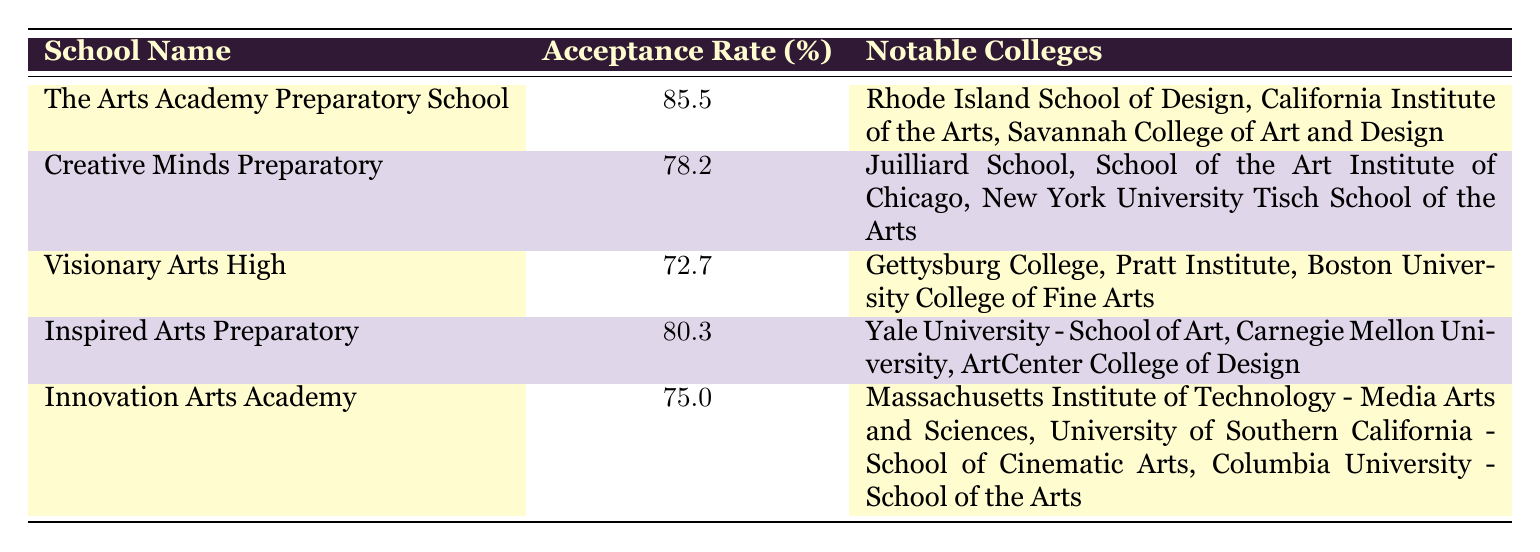What is the college acceptance rate for The Arts Academy Preparatory School? The college acceptance rate for The Arts Academy Preparatory School is listed in the table. According to the data, it is 85.5 percent.
Answer: 85.5 Which school has the lowest college acceptance rate, and what is that rate? By examining the table, I see that Visionary Arts High has the lowest college acceptance rate at 72.7 percent.
Answer: Visionary Arts High, 72.7 What are the notable colleges for Inspired Arts Preparatory? The table lists the notable colleges for Inspired Arts Preparatory, which include Yale University - School of Art, Carnegie Mellon University, and ArtCenter College of Design.
Answer: Yale University - School of Art, Carnegie Mellon University, ArtCenter College of Design What is the average college acceptance rate for the schools listed? To calculate the average college acceptance rate, I sum the rates: (85.5 + 78.2 + 72.7 + 80.3 + 75.0) = 391.7. Then, I divide by the number of schools, which is 5. Thus, the average is 391.7 / 5 = 78.34.
Answer: 78.34 Is the college acceptance rate for Innovation Arts Academy higher than that for Creative Minds Preparatory? Comparing the two rates in the table, Innovation Arts Academy has a college acceptance rate of 75.0, while Creative Minds Preparatory has a rate of 78.2. Since 75.0 is less than 78.2, the answer is no.
Answer: No Which school has a college acceptance rate greater than 80 percent? Looking at the table, I notice that The Arts Academy Preparatory School with 85.5 and Inspired Arts Preparatory with 80.3 both have acceptance rates over 80 percent.
Answer: The Arts Academy Preparatory School, Inspired Arts Preparatory Are any notable colleges mentioned for the Visionary Arts High School? The table shows the notable colleges for Visionary Arts High. They are Gettysburg College, Pratt Institute, and Boston University College of Fine Arts, confirming that notable colleges are indeed listed.
Answer: Yes What is the difference in college acceptance rates between The Arts Academy Preparatory School and Visionary Arts High? The college acceptance rate for The Arts Academy Preparatory School is 85.5, and for Visionary Arts High, it is 72.7. To find the difference, I subtract: 85.5 - 72.7 = 12.8.
Answer: 12.8 